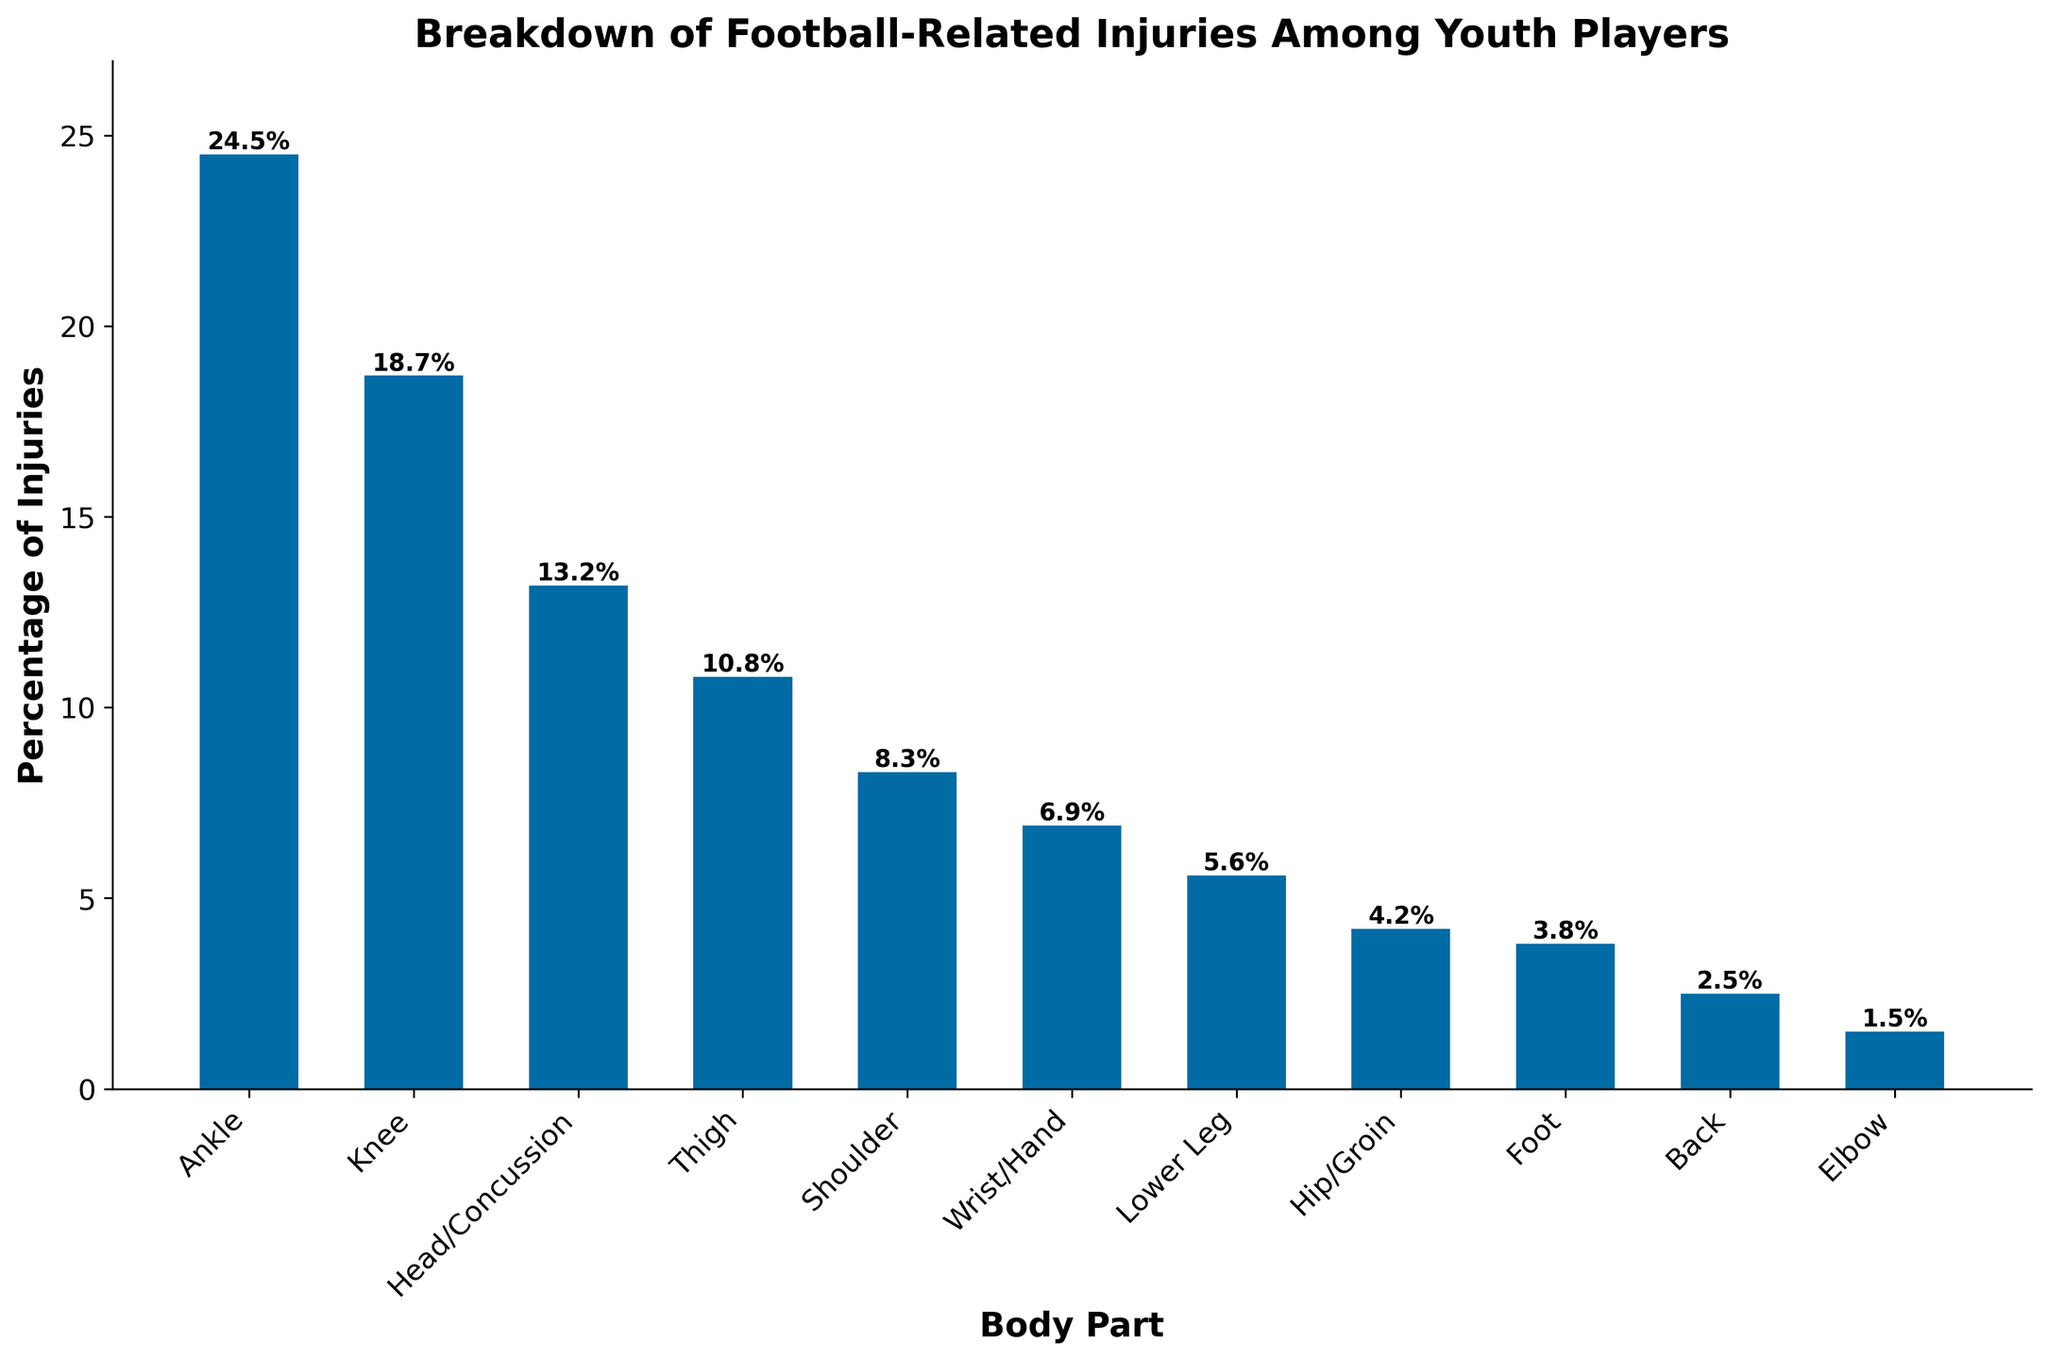What body part has the highest percentage of injuries? To find the body part with the highest percentage of injuries, look for the tallest bar in the bar chart.
Answer: Ankle How much higher is the percentage of ankle injuries compared to knee injuries? Find the percentages for ankle and knee injuries. The percentage of ankle injuries is 24.5% and that of knee injuries is 18.7%. Subtract 18.7% from 24.5% to find the difference.
Answer: 5.8% Which body part has the lowest percentage of injuries? Locate the shortest bar in the bar chart to determine the body part with the lowest percentage of injuries.
Answer: Elbow How many percentage points more injuries does the head have compared to the shoulder? Find the percentages for head/concussion and shoulder injuries. Head injuries are 13.2% and shoulder injuries are 8.3%. Subtract 8.3% from 13.2% to get the difference.
Answer: 4.9% What is the total percentage of injuries for the ankle, knee, and thigh combined? Add the percentages for ankle (24.5%), knee (18.7%), and thigh (10.8%) injuries together. 24.5% + 18.7% + 10.8% = 54%
Answer: 54% Which has more injuries, the hip/groin or the wrist/hand? Compare the bar heights of hip/groin and wrist/hand. Hip/groin is 4.2% and wrist/hand is 6.9%.
Answer: Wrist/hand By how many percent is the percentage of lower leg injuries greater than elbow injuries? Find the percentages for lower leg (5.6%) and elbow (1.5%) injuries. Subtract 1.5% from 5.6% to find the difference.
Answer: 4.1% What is the average percentage of injuries for the top four body parts? Add the percentages for ankle (24.5%), knee (18.7%), head/concussion (13.2%), and thigh (10.8%) injuries, then divide by 4. (24.5 + 18.7 + 13.2 + 10.8) / 4 = 67.2 / 4
Answer: 16.8% How does the percentage of back injuries compare to the percentage of hip/groin injuries? Look at the bar heights for back and hip/groin injuries. Back injuries are 2.5% and hip/groin injuries are 4.2%.
Answer: Back injuries are lower What is the difference between the highest and lowest percentages of injuries presented? Identify the highest percentage (ankle, 24.5%) and the lowest percentage (elbow, 1.5%), then subtract the lowest from the highest. 24.5% - 1.5% = 23%
Answer: 23% 